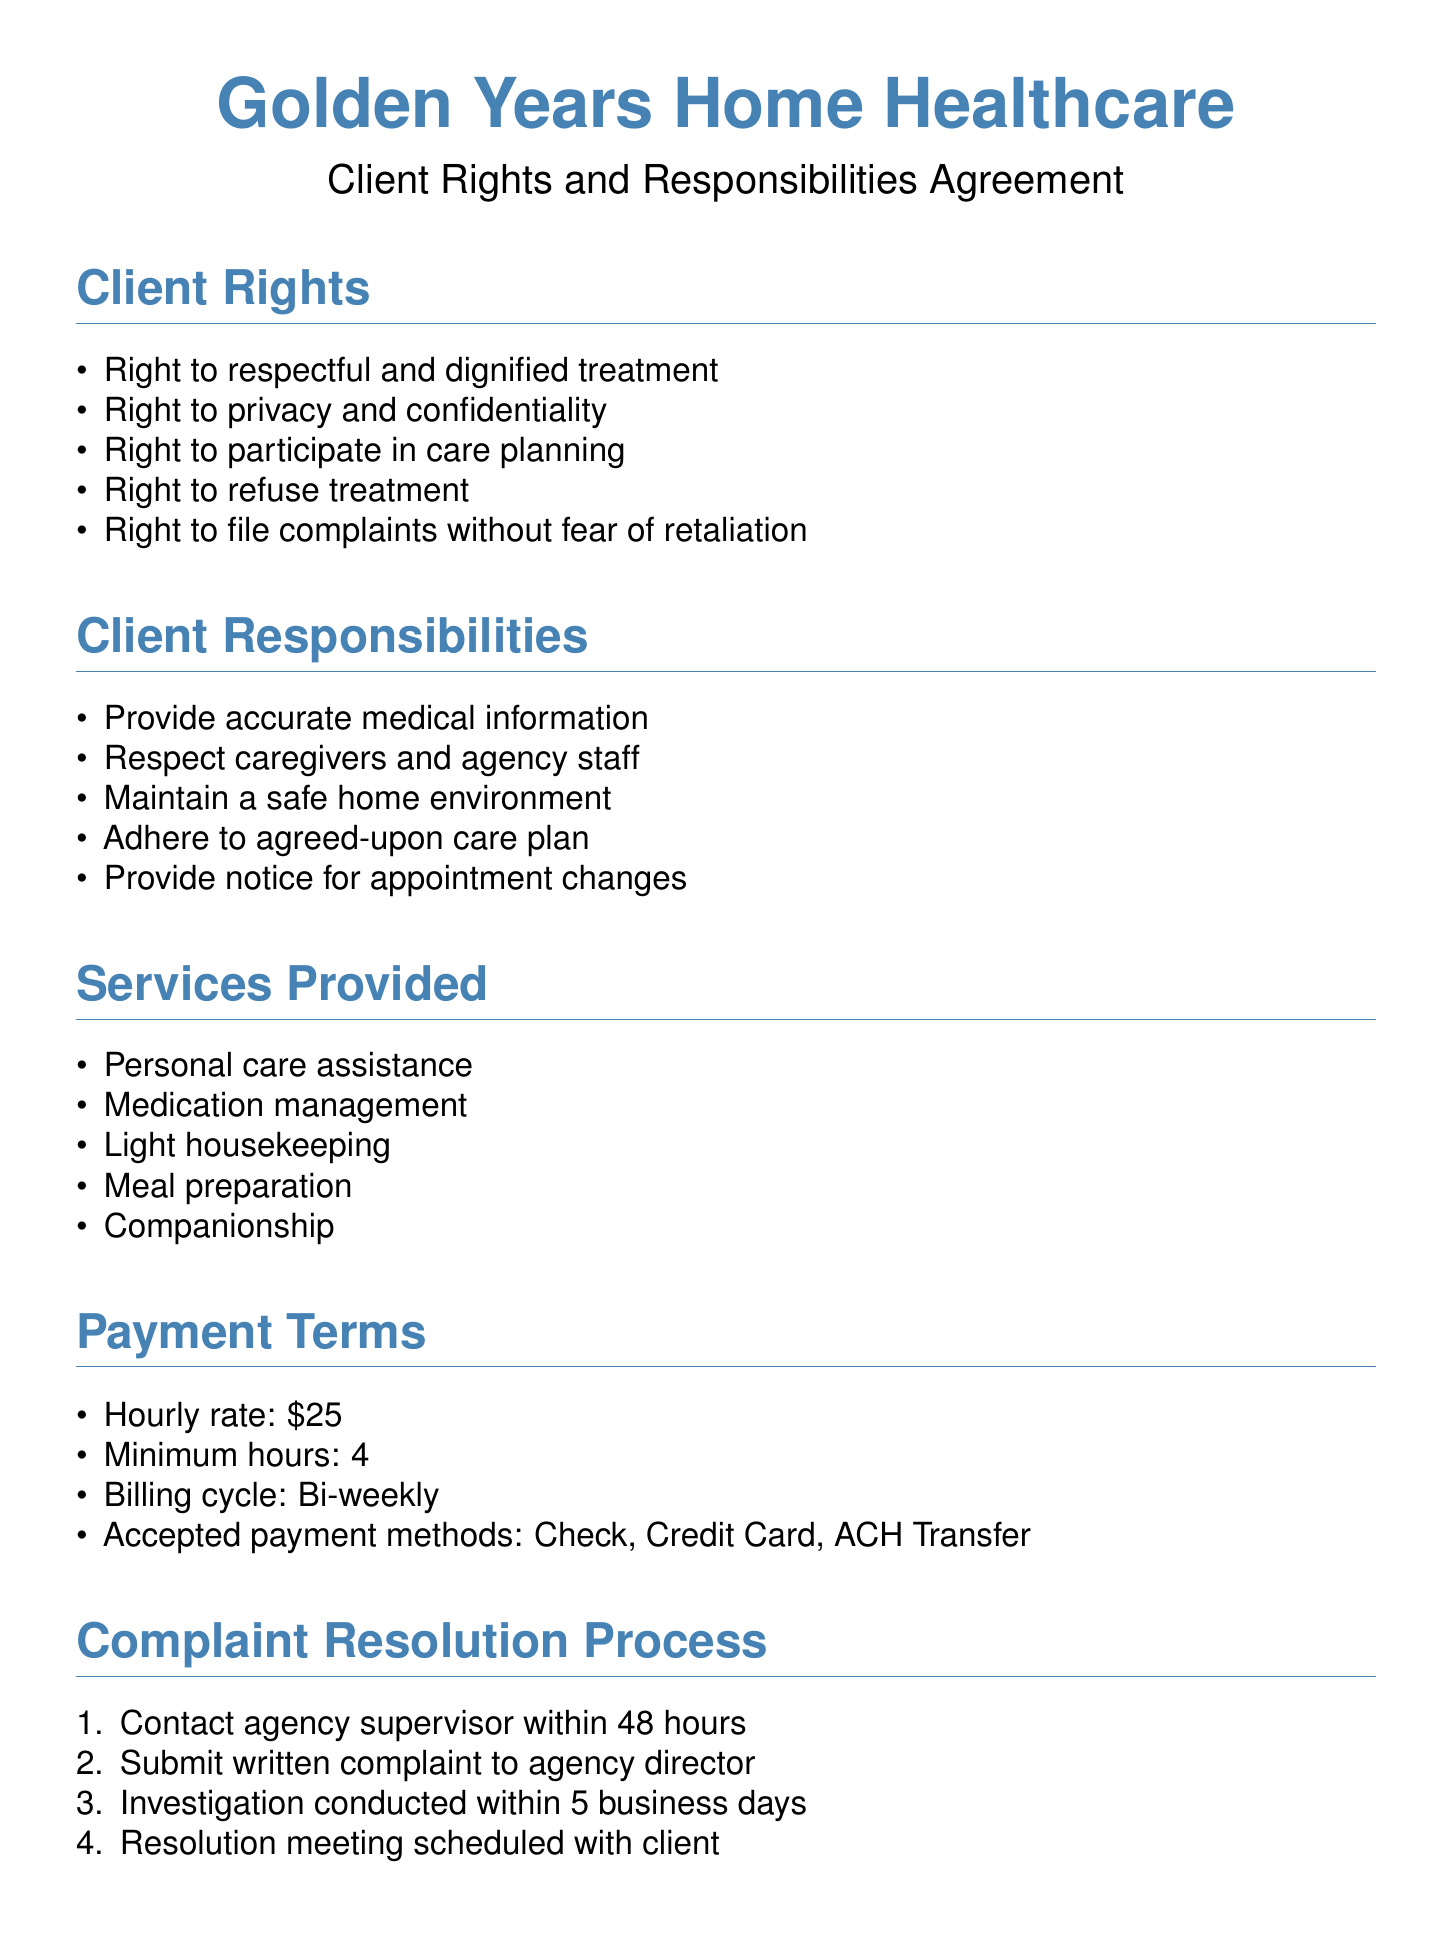What is the agency's hourly rate? The hourly rate for services provided is mentioned in the payment terms section of the document.
Answer: $25 Who should a client contact within 48 hours of a complaint? The complaint resolution process specifies who to contact within a set timeframe.
Answer: Agency supervisor What is the minimum number of hours for service? The payment terms detail the minimum hours required for service.
Answer: 4 What services are provided by the agency? The document outlines the types of services offered, which are listed under services provided.
Answer: Personal care assistance What is the billing cycle for payments? The payment terms section of the document specifies how frequently clients are billed.
Answer: Bi-weekly What rights do clients have regarding treatment? The rights of clients include specific entitlements that are detailed in the client rights section.
Answer: Refuse treatment How long does the agency take to investigate a complaint? The complaint resolution process outlines the time frame for conducting investigations.
Answer: 5 business days Who is the emergency contact person? The emergency contact section provides the name and position of the designated individual for urgent matters.
Answer: Sarah Thompson What should a client provide to maintain a safe home environment? The client responsibilities portion details what clients must do to ensure safety at home.
Answer: Accurate medical information 